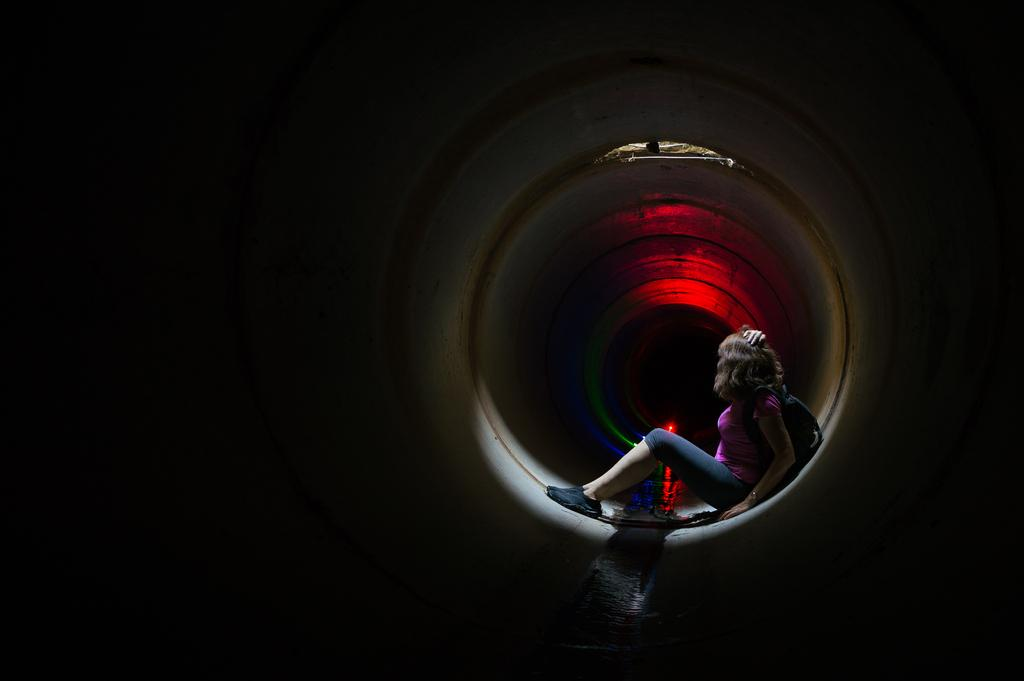What is the primary subject in the image? There is a woman sitting in the image. What object can be seen in the image besides the woman? There is a pipe in the image. Can you describe the lighting in the image? There is background lighting visible in the image. How many snails are crawling on the woman's shoulder in the image? There are no snails visible in the image. Is the woman playing baseball in the image? There is no indication of a baseball game or any baseball-related activity in the image. 